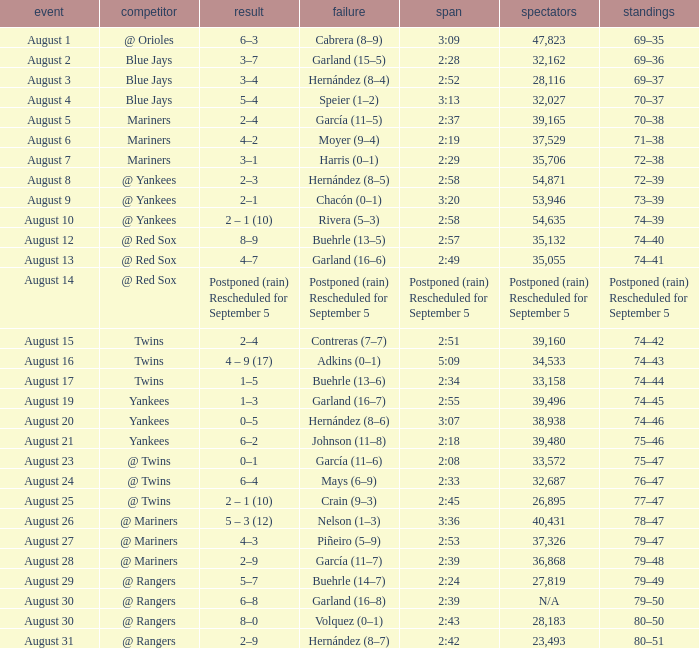Who lost with a time of 2:42? Hernández (8–7). I'm looking to parse the entire table for insights. Could you assist me with that? {'header': ['event', 'competitor', 'result', 'failure', 'span', 'spectators', 'standings'], 'rows': [['August 1', '@ Orioles', '6–3', 'Cabrera (8–9)', '3:09', '47,823', '69–35'], ['August 2', 'Blue Jays', '3–7', 'Garland (15–5)', '2:28', '32,162', '69–36'], ['August 3', 'Blue Jays', '3–4', 'Hernández (8–4)', '2:52', '28,116', '69–37'], ['August 4', 'Blue Jays', '5–4', 'Speier (1–2)', '3:13', '32,027', '70–37'], ['August 5', 'Mariners', '2–4', 'García (11–5)', '2:37', '39,165', '70–38'], ['August 6', 'Mariners', '4–2', 'Moyer (9–4)', '2:19', '37,529', '71–38'], ['August 7', 'Mariners', '3–1', 'Harris (0–1)', '2:29', '35,706', '72–38'], ['August 8', '@ Yankees', '2–3', 'Hernández (8–5)', '2:58', '54,871', '72–39'], ['August 9', '@ Yankees', '2–1', 'Chacón (0–1)', '3:20', '53,946', '73–39'], ['August 10', '@ Yankees', '2 – 1 (10)', 'Rivera (5–3)', '2:58', '54,635', '74–39'], ['August 12', '@ Red Sox', '8–9', 'Buehrle (13–5)', '2:57', '35,132', '74–40'], ['August 13', '@ Red Sox', '4–7', 'Garland (16–6)', '2:49', '35,055', '74–41'], ['August 14', '@ Red Sox', 'Postponed (rain) Rescheduled for September 5', 'Postponed (rain) Rescheduled for September 5', 'Postponed (rain) Rescheduled for September 5', 'Postponed (rain) Rescheduled for September 5', 'Postponed (rain) Rescheduled for September 5'], ['August 15', 'Twins', '2–4', 'Contreras (7–7)', '2:51', '39,160', '74–42'], ['August 16', 'Twins', '4 – 9 (17)', 'Adkins (0–1)', '5:09', '34,533', '74–43'], ['August 17', 'Twins', '1–5', 'Buehrle (13–6)', '2:34', '33,158', '74–44'], ['August 19', 'Yankees', '1–3', 'Garland (16–7)', '2:55', '39,496', '74–45'], ['August 20', 'Yankees', '0–5', 'Hernández (8–6)', '3:07', '38,938', '74–46'], ['August 21', 'Yankees', '6–2', 'Johnson (11–8)', '2:18', '39,480', '75–46'], ['August 23', '@ Twins', '0–1', 'García (11–6)', '2:08', '33,572', '75–47'], ['August 24', '@ Twins', '6–4', 'Mays (6–9)', '2:33', '32,687', '76–47'], ['August 25', '@ Twins', '2 – 1 (10)', 'Crain (9–3)', '2:45', '26,895', '77–47'], ['August 26', '@ Mariners', '5 – 3 (12)', 'Nelson (1–3)', '3:36', '40,431', '78–47'], ['August 27', '@ Mariners', '4–3', 'Piñeiro (5–9)', '2:53', '37,326', '79–47'], ['August 28', '@ Mariners', '2–9', 'García (11–7)', '2:39', '36,868', '79–48'], ['August 29', '@ Rangers', '5–7', 'Buehrle (14–7)', '2:24', '27,819', '79–49'], ['August 30', '@ Rangers', '6–8', 'Garland (16–8)', '2:39', 'N/A', '79–50'], ['August 30', '@ Rangers', '8–0', 'Volquez (0–1)', '2:43', '28,183', '80–50'], ['August 31', '@ Rangers', '2–9', 'Hernández (8–7)', '2:42', '23,493', '80–51']]} 